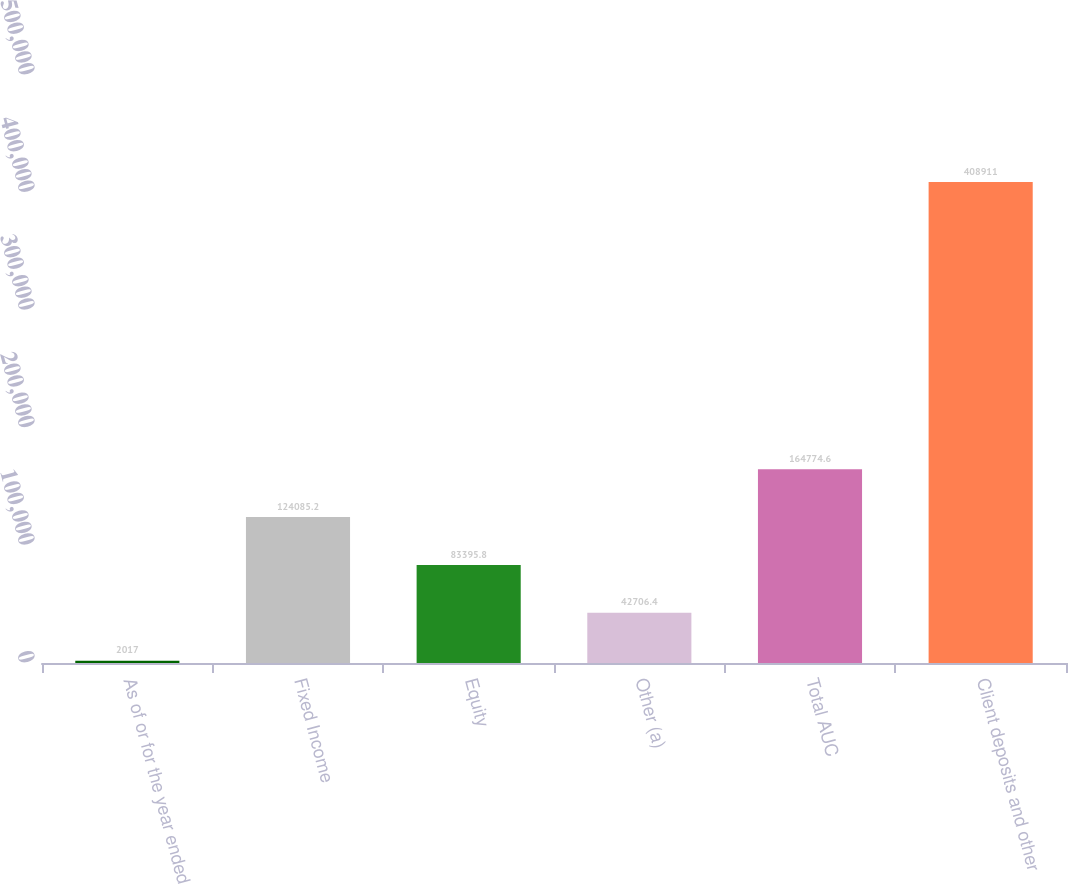Convert chart to OTSL. <chart><loc_0><loc_0><loc_500><loc_500><bar_chart><fcel>As of or for the year ended<fcel>Fixed Income<fcel>Equity<fcel>Other (a)<fcel>Total AUC<fcel>Client deposits and other<nl><fcel>2017<fcel>124085<fcel>83395.8<fcel>42706.4<fcel>164775<fcel>408911<nl></chart> 